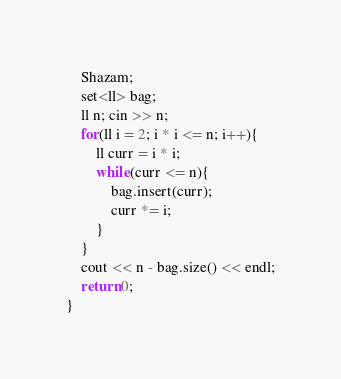<code> <loc_0><loc_0><loc_500><loc_500><_C++_>    Shazam;
    set<ll> bag;
    ll n; cin >> n;
    for(ll i = 2; i * i <= n; i++){
        ll curr = i * i;
        while(curr <= n){
            bag.insert(curr);
            curr *= i;
        }
    }
    cout << n - bag.size() << endl;
    return 0;
}</code> 